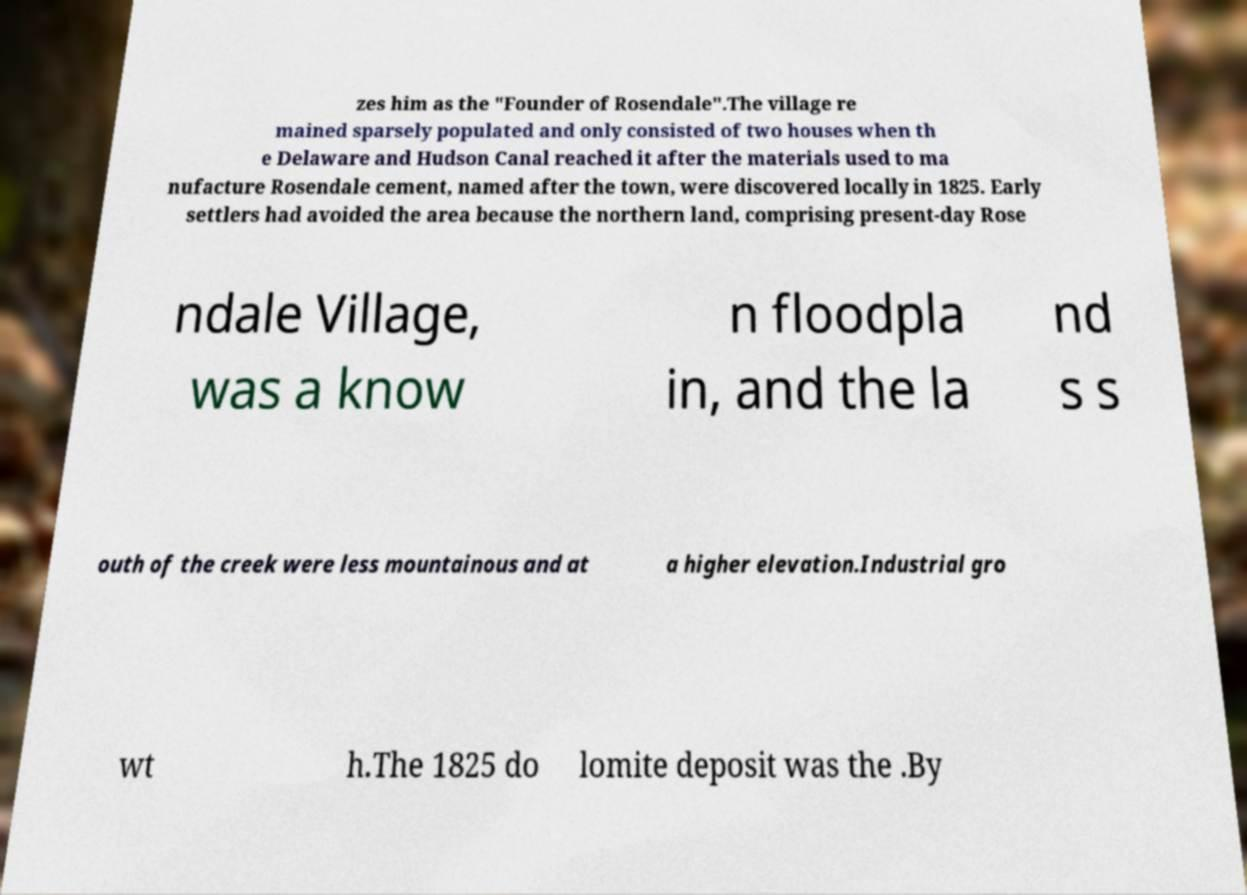I need the written content from this picture converted into text. Can you do that? zes him as the "Founder of Rosendale".The village re mained sparsely populated and only consisted of two houses when th e Delaware and Hudson Canal reached it after the materials used to ma nufacture Rosendale cement, named after the town, were discovered locally in 1825. Early settlers had avoided the area because the northern land, comprising present-day Rose ndale Village, was a know n floodpla in, and the la nd s s outh of the creek were less mountainous and at a higher elevation.Industrial gro wt h.The 1825 do lomite deposit was the .By 